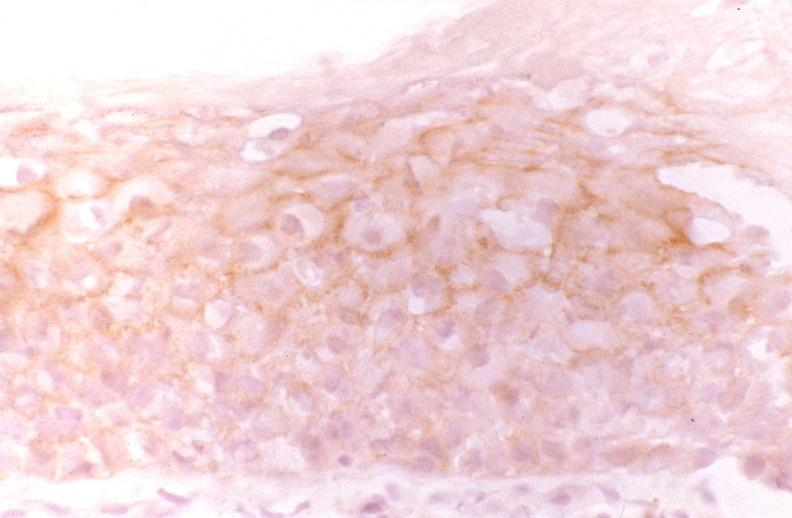what is present?
Answer the question using a single word or phrase. Gastrointestinal 